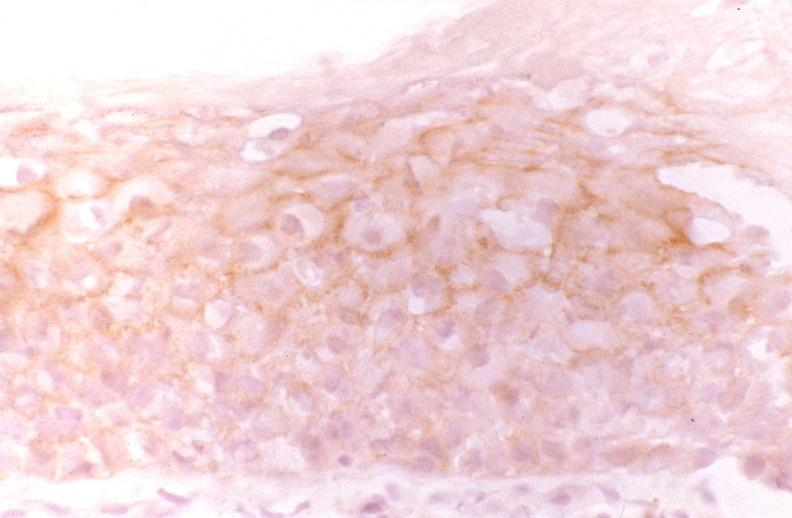what is present?
Answer the question using a single word or phrase. Gastrointestinal 